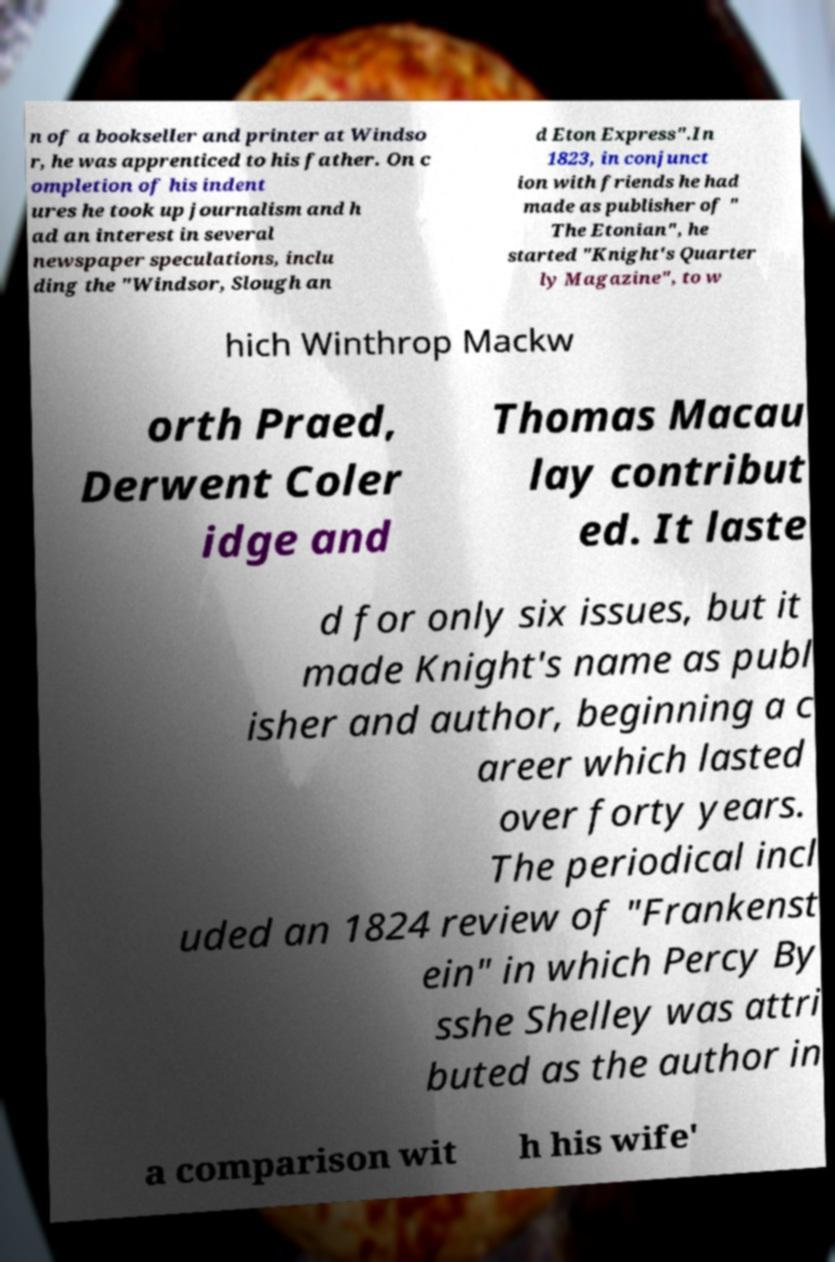What messages or text are displayed in this image? I need them in a readable, typed format. n of a bookseller and printer at Windso r, he was apprenticed to his father. On c ompletion of his indent ures he took up journalism and h ad an interest in several newspaper speculations, inclu ding the "Windsor, Slough an d Eton Express".In 1823, in conjunct ion with friends he had made as publisher of " The Etonian", he started "Knight's Quarter ly Magazine", to w hich Winthrop Mackw orth Praed, Derwent Coler idge and Thomas Macau lay contribut ed. It laste d for only six issues, but it made Knight's name as publ isher and author, beginning a c areer which lasted over forty years. The periodical incl uded an 1824 review of "Frankenst ein" in which Percy By sshe Shelley was attri buted as the author in a comparison wit h his wife' 